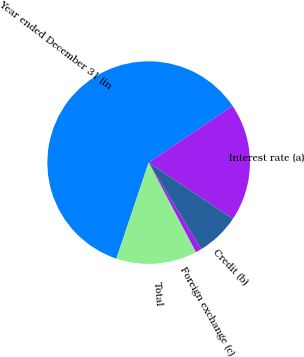Convert chart. <chart><loc_0><loc_0><loc_500><loc_500><pie_chart><fcel>Year ended December 31 (in<fcel>Interest rate (a)<fcel>Credit (b)<fcel>Foreign exchange (c)<fcel>Total<nl><fcel>60.4%<fcel>18.81%<fcel>6.93%<fcel>0.99%<fcel>12.87%<nl></chart> 